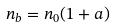Convert formula to latex. <formula><loc_0><loc_0><loc_500><loc_500>n _ { b } = n _ { 0 } ( 1 + a )</formula> 